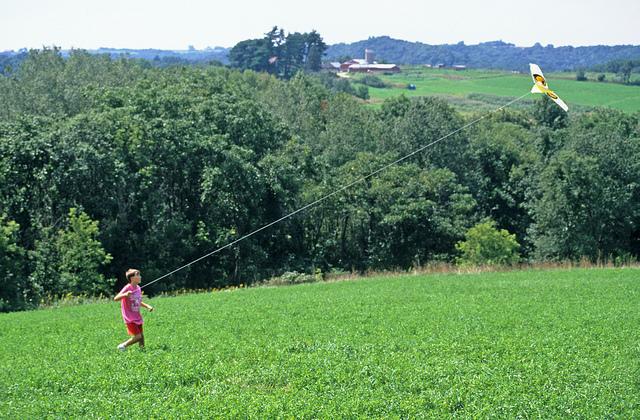What is the kid flying?
Answer briefly. Kite. What time of day is it?
Give a very brief answer. Afternoon. Where is the child playing?
Keep it brief. Field. 